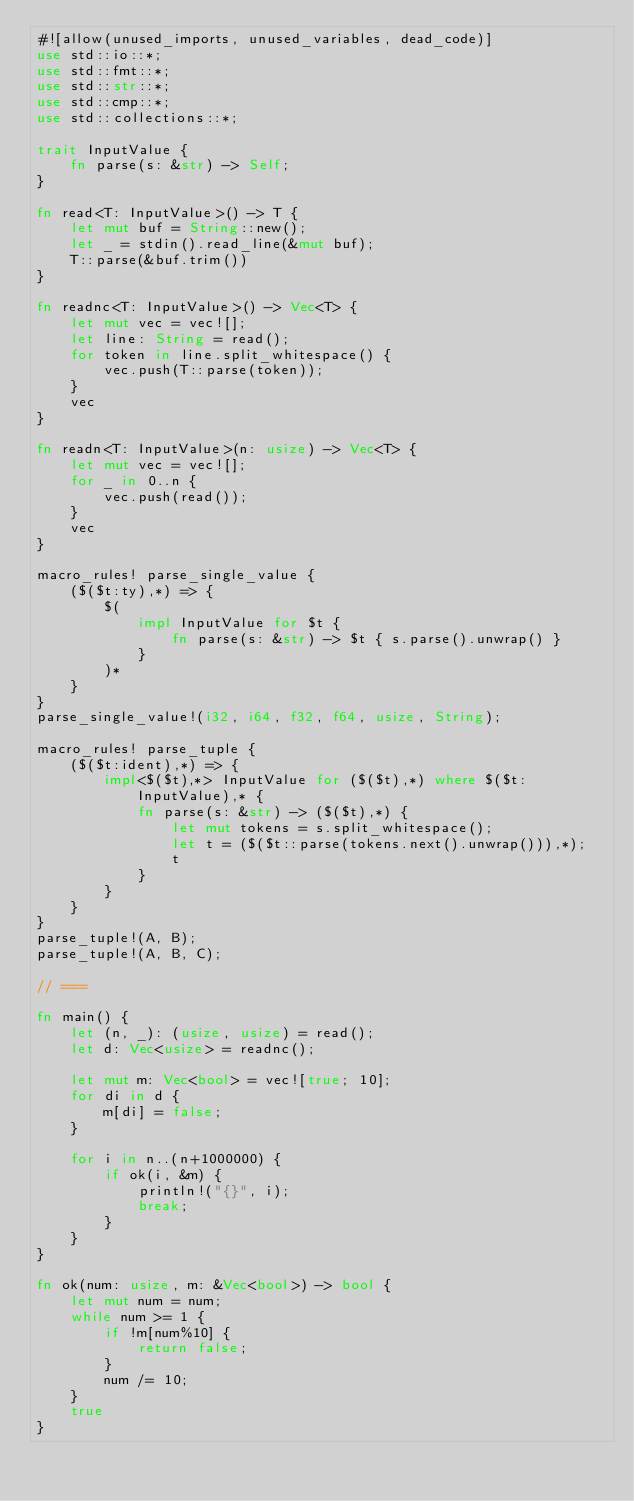<code> <loc_0><loc_0><loc_500><loc_500><_Rust_>#![allow(unused_imports, unused_variables, dead_code)]
use std::io::*;
use std::fmt::*;
use std::str::*;
use std::cmp::*;
use std::collections::*;

trait InputValue {
    fn parse(s: &str) -> Self;
}

fn read<T: InputValue>() -> T {
    let mut buf = String::new();
    let _ = stdin().read_line(&mut buf);
    T::parse(&buf.trim())
}

fn readnc<T: InputValue>() -> Vec<T> {
    let mut vec = vec![];
    let line: String = read();
    for token in line.split_whitespace() {
        vec.push(T::parse(token));
    }
    vec
}

fn readn<T: InputValue>(n: usize) -> Vec<T> {
    let mut vec = vec![];
    for _ in 0..n {
        vec.push(read());
    }
    vec
}

macro_rules! parse_single_value {
    ($($t:ty),*) => {
        $(
            impl InputValue for $t {
                fn parse(s: &str) -> $t { s.parse().unwrap() }
            }
        )*
	}
}
parse_single_value!(i32, i64, f32, f64, usize, String);

macro_rules! parse_tuple {
	($($t:ident),*) => {
		impl<$($t),*> InputValue for ($($t),*) where $($t: InputValue),* {
			fn parse(s: &str) -> ($($t),*) {
				let mut tokens = s.split_whitespace();
				let t = ($($t::parse(tokens.next().unwrap())),*);
				t
			}
		}
	}
}
parse_tuple!(A, B);
parse_tuple!(A, B, C);

// ===

fn main() {
    let (n, _): (usize, usize) = read();
    let d: Vec<usize> = readnc();

    let mut m: Vec<bool> = vec![true; 10];
    for di in d {
        m[di] = false;
    }

    for i in n..(n+1000000) {
        if ok(i, &m) {
            println!("{}", i);
            break;
        }
    }
}

fn ok(num: usize, m: &Vec<bool>) -> bool {
    let mut num = num;
    while num >= 1 {
        if !m[num%10] {
            return false;
        }
        num /= 10;
    }
    true
}</code> 